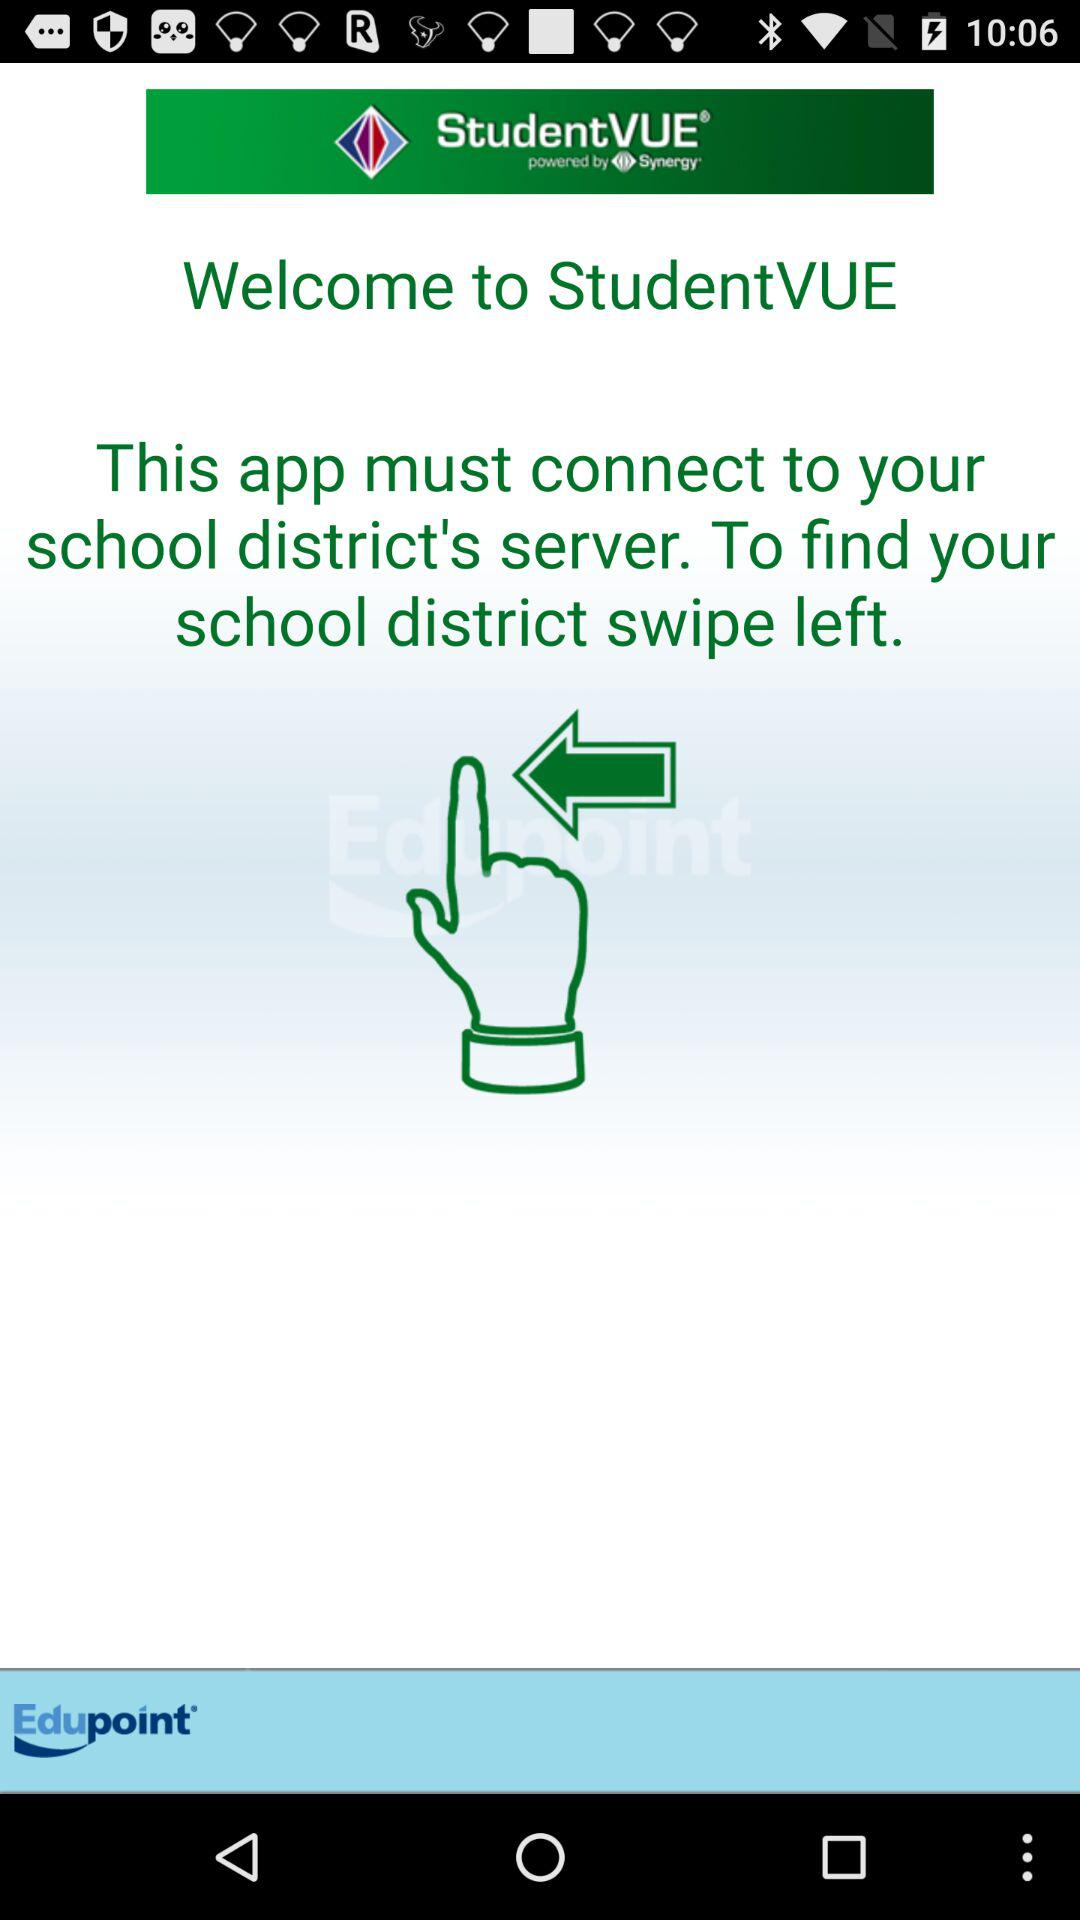What is the application name? The application name is "StudentVUE". 